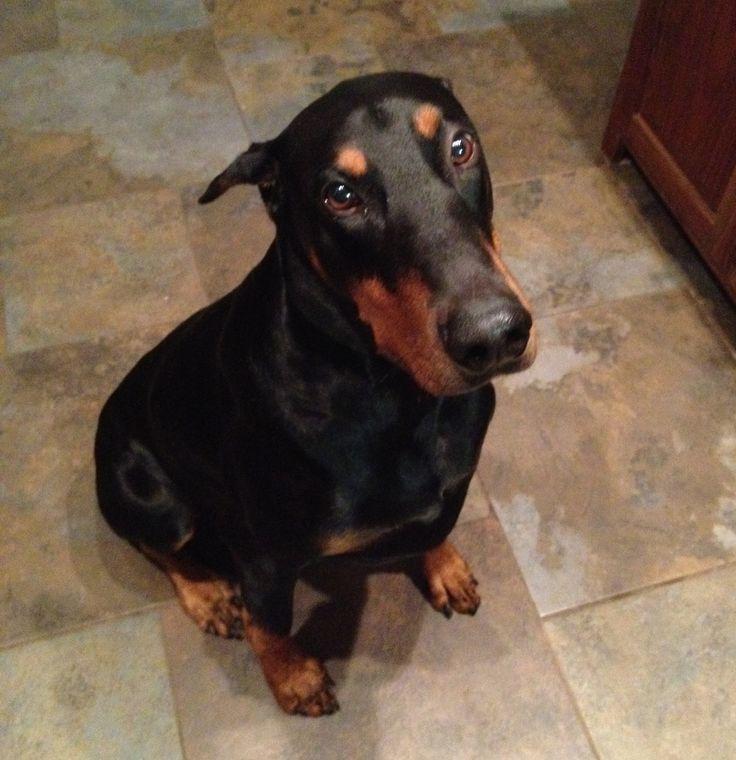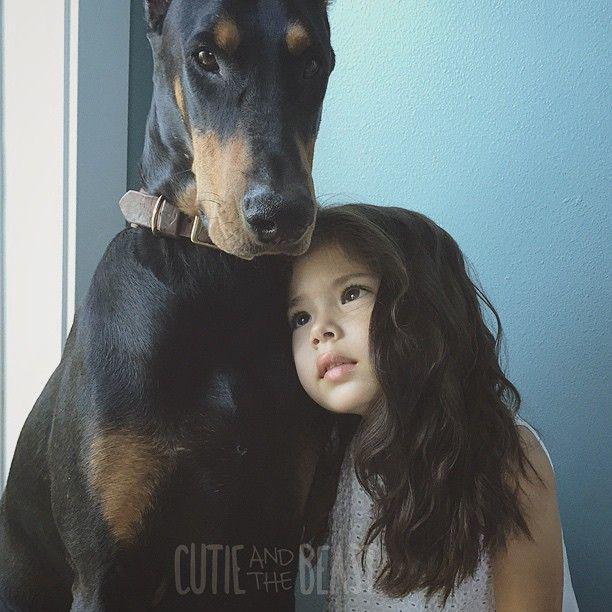The first image is the image on the left, the second image is the image on the right. Evaluate the accuracy of this statement regarding the images: "In the image on the right, a dog is looking to the left.". Is it true? Answer yes or no. No. The first image is the image on the left, the second image is the image on the right. Considering the images on both sides, is "There are two dogs, and one of the dogs has cropped ears, while the other dog's ears are uncropped." valid? Answer yes or no. No. 